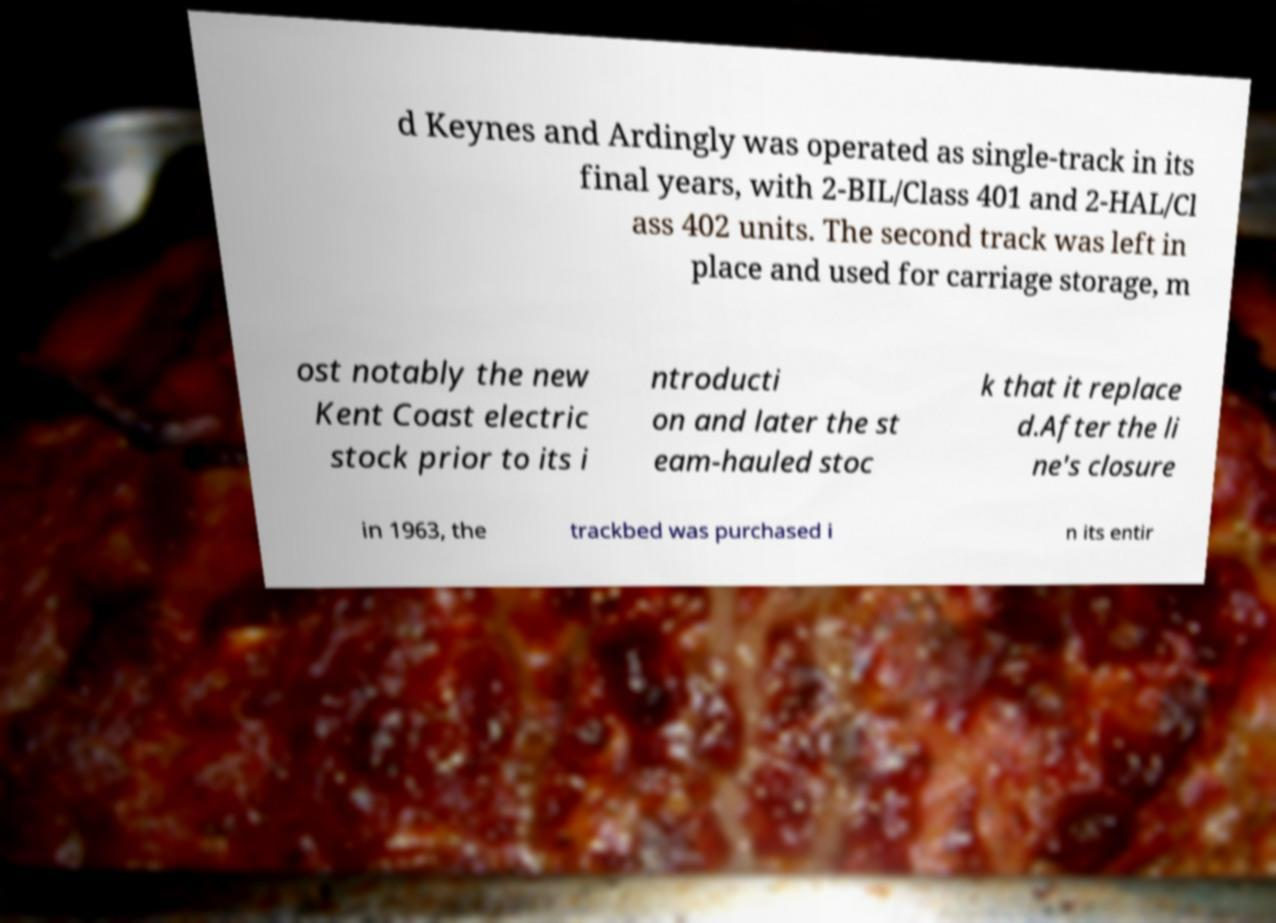Can you accurately transcribe the text from the provided image for me? d Keynes and Ardingly was operated as single-track in its final years, with 2-BIL/Class 401 and 2-HAL/Cl ass 402 units. The second track was left in place and used for carriage storage, m ost notably the new Kent Coast electric stock prior to its i ntroducti on and later the st eam-hauled stoc k that it replace d.After the li ne's closure in 1963, the trackbed was purchased i n its entir 